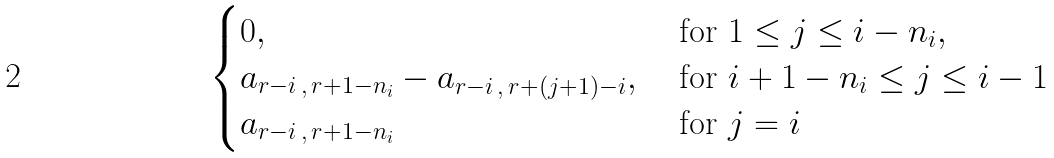Convert formula to latex. <formula><loc_0><loc_0><loc_500><loc_500>\begin{cases} 0 , & \text { for } 1 \leq j \leq i - n _ { i } , \\ a _ { r - i \, , \, r + 1 - n _ { i } } - a _ { r - i \, , \, r + ( j + 1 ) - i } , & \text { for } i + 1 - n _ { i } \leq j \leq i - 1 \\ a _ { r - i \, , \, r + 1 - n _ { i } } & \text { for } j = i \end{cases}</formula> 